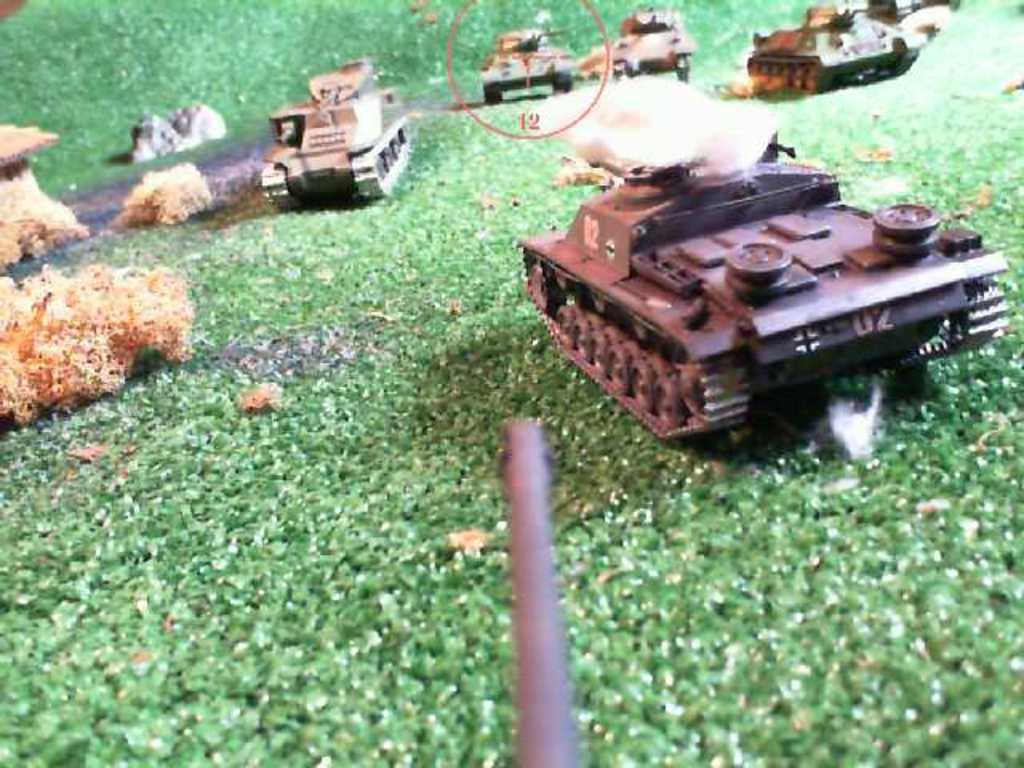What type of objects are present in the image? There are toy vehicles in the image. What can be found at the bottom of the image? There is a sponge at the bottom of the image. Where is the gun located in the image? The gun is in the center of the image. What letters are written on the toy vehicles in the image? There are no letters written on the toy vehicles in the image. How does the wind affect the gun in the image? There is no wind present in the image, so it cannot affect the gun. 